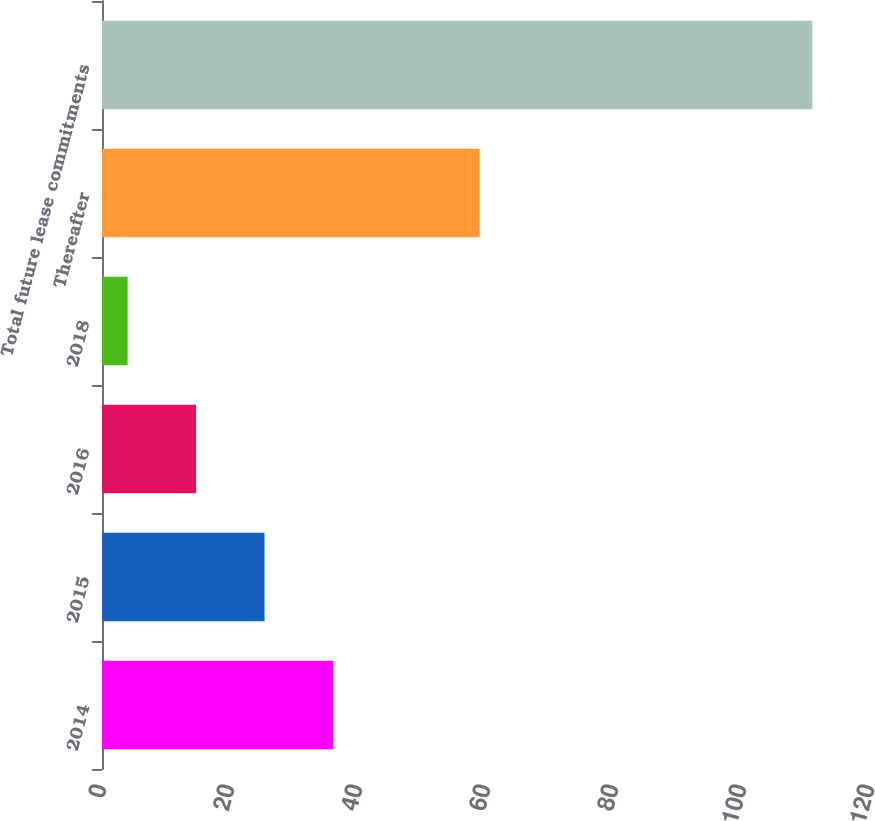Convert chart. <chart><loc_0><loc_0><loc_500><loc_500><bar_chart><fcel>2014<fcel>2015<fcel>2016<fcel>2018<fcel>Thereafter<fcel>Total future lease commitments<nl><fcel>36.1<fcel>25.4<fcel>14.7<fcel>4<fcel>59<fcel>111<nl></chart> 